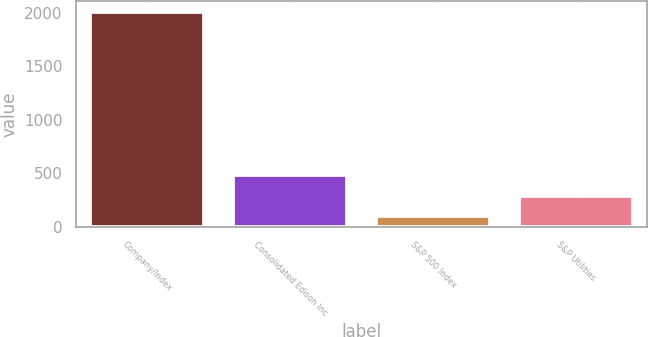Convert chart to OTSL. <chart><loc_0><loc_0><loc_500><loc_500><bar_chart><fcel>Company/Index<fcel>Consolidated Edison Inc<fcel>S&P 500 Index<fcel>S&P Utilities<nl><fcel>2011<fcel>481.2<fcel>98.76<fcel>289.98<nl></chart> 